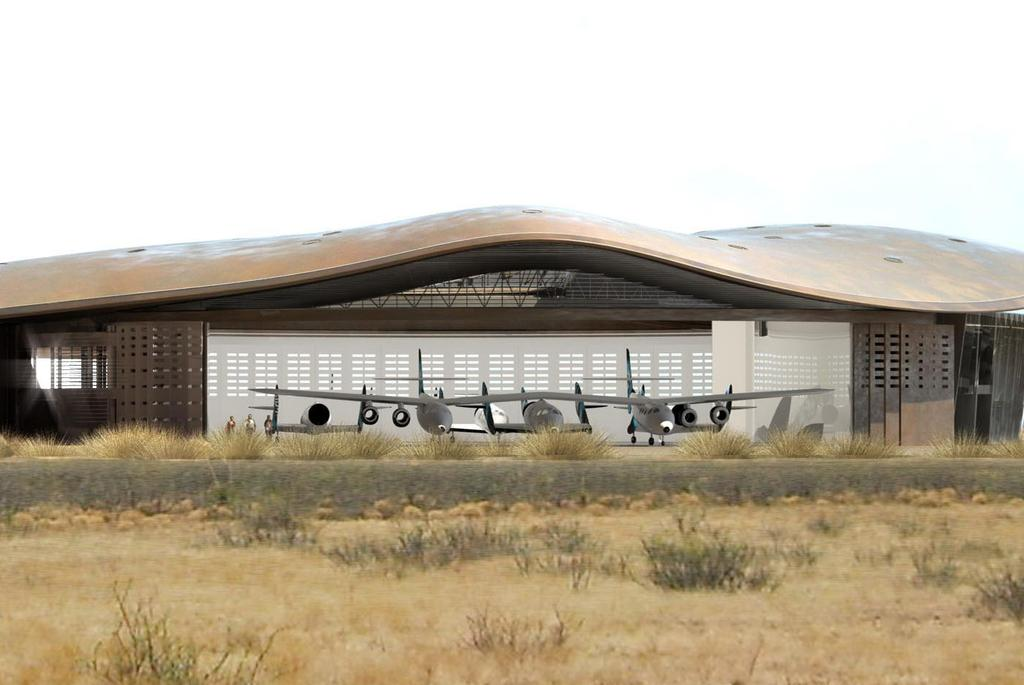What is the main structure in the image? There is a building in the image. What is located in front of the building? There are airplanes, people, grass, plants, and stones in front of the building. Can you describe the people in the image? The image only shows people in front of the building, but their specific actions or characteristics are not mentioned. What is visible in the background of the image? The sky is visible in the background of the image. How many cats can be seen playing in the park in the image? There are no cats or park present in the image; it features a building with various elements in front of it and a visible sky in the background. 